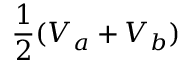<formula> <loc_0><loc_0><loc_500><loc_500>\frac { 1 } { 2 } ( V _ { a } + V _ { b } )</formula> 